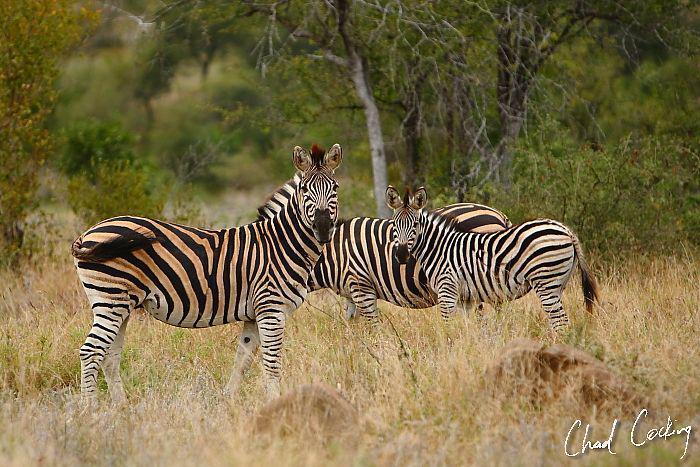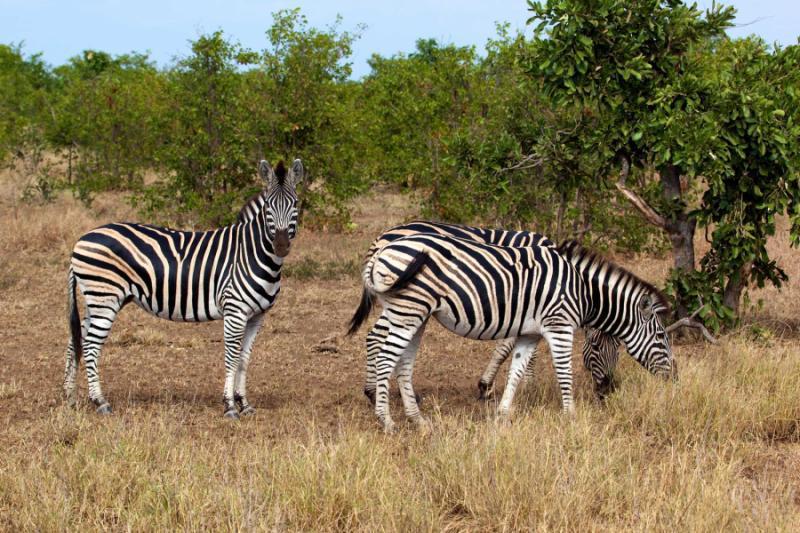The first image is the image on the left, the second image is the image on the right. Evaluate the accuracy of this statement regarding the images: "In the foreground of the lefthand image, two zebras stand with bodies turned toward each other and faces turned to the camera.". Is it true? Answer yes or no. Yes. 